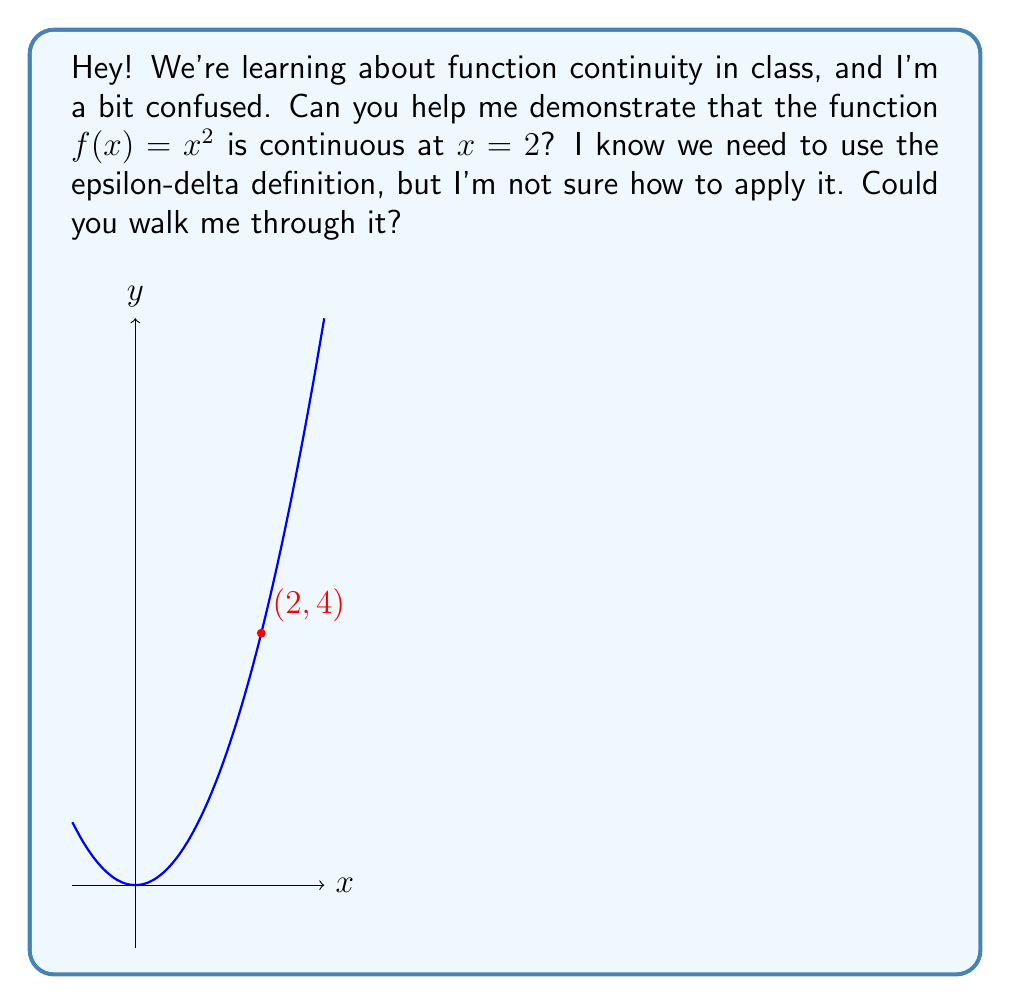Help me with this question. Sure! Let's break this down step-by-step:

1) To show that $f(x) = x^2$ is continuous at $x = 2$, we need to prove that for any $\epsilon > 0$, there exists a $\delta > 0$ such that:

   If $|x - 2| < \delta$, then $|f(x) - f(2)| < \epsilon$

2) Let's start by simplifying $|f(x) - f(2)|$:
   $|f(x) - f(2)| = |x^2 - 2^2| = |x^2 - 4|$

3) Now, we can factor this:
   $|x^2 - 4| = |(x+2)(x-2)|$

4) We're looking at points close to $x = 2$, so $|x+2|$ will be close to 4. Let's say $|x+2| < 5$ for these nearby points.

5) Using this, we can say:
   $|(x+2)(x-2)| \leq 5|x-2|$

6) So, if we want $|f(x) - f(2)| < \epsilon$, it's enough to have:
   $5|x-2| < \epsilon$

7) Solving this for $|x-2|$, we get:
   $|x-2| < \frac{\epsilon}{5}$

8) Therefore, we can choose $\delta = \frac{\epsilon}{5}$

9) With this choice of $\delta$, whenever $|x-2| < \delta$, we'll have:
   $|f(x) - f(2)| < \epsilon$

This proves that $f(x) = x^2$ is continuous at $x = 2$.
Answer: $f(x) = x^2$ is continuous at $x = 2$ with $\delta = \frac{\epsilon}{5}$. 